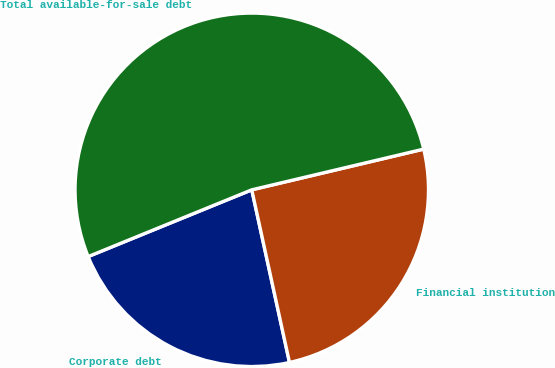<chart> <loc_0><loc_0><loc_500><loc_500><pie_chart><fcel>Corporate debt<fcel>Financial institution<fcel>Total available-for-sale debt<nl><fcel>22.26%<fcel>25.28%<fcel>52.47%<nl></chart> 